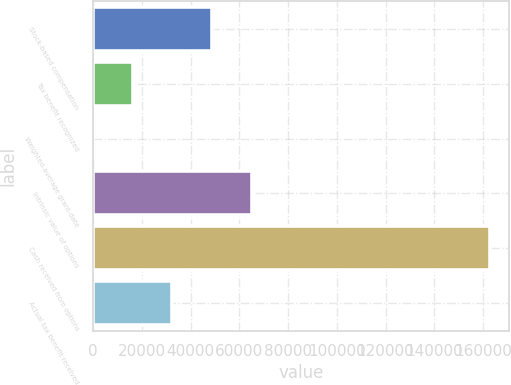Convert chart to OTSL. <chart><loc_0><loc_0><loc_500><loc_500><bar_chart><fcel>Stock-based compensation<fcel>Tax benefit recognized<fcel>Weighted-average grant-date<fcel>Intrinsic value of options<fcel>Cash received from options<fcel>Actual tax benefit received<nl><fcel>48794.7<fcel>16275.2<fcel>15.48<fcel>65054.5<fcel>162613<fcel>32535<nl></chart> 